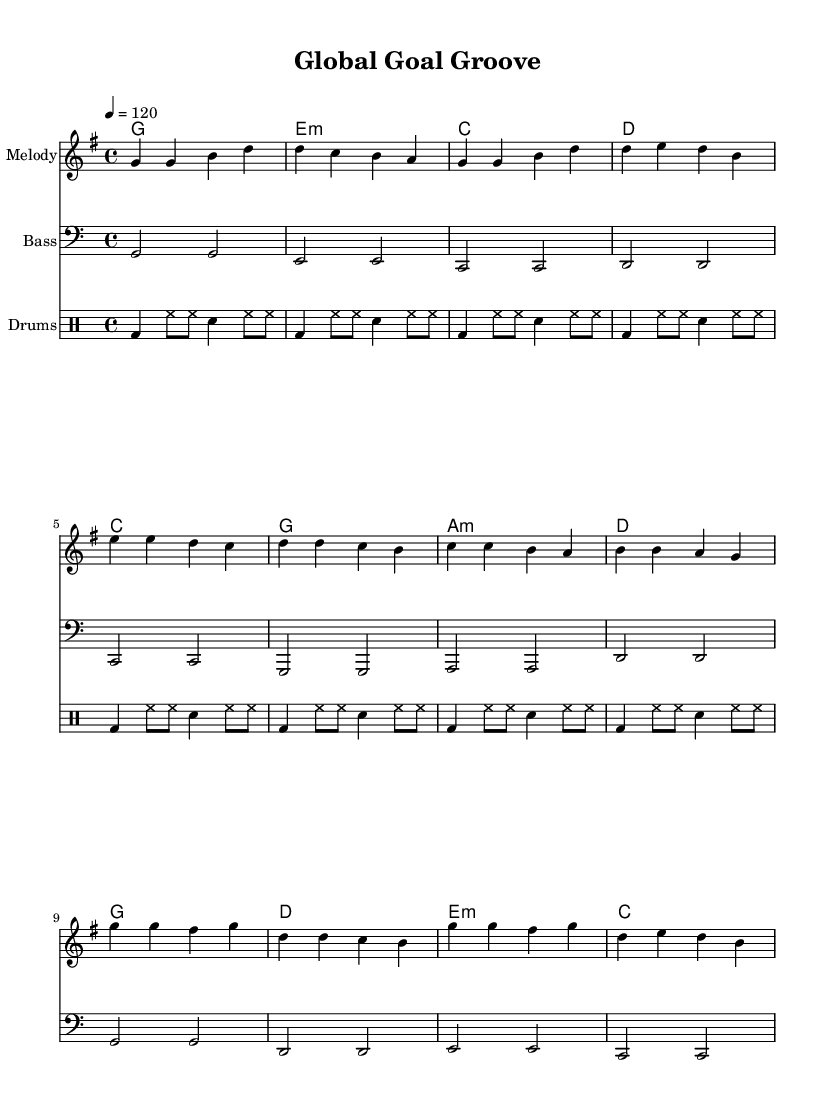What is the key signature of this music? The key signature is G major, which has one sharp (F#). This can be determined by looking at the key signature indicated at the beginning of the score, where there's a single sharp on the staff.
Answer: G major What is the time signature of this music? The time signature is 4/4, shown at the start of the score. This means there are four beats per measure, and the quarter note receives one beat.
Answer: 4/4 What is the tempo marking of this music? The tempo marking is 120 beats per minute (BPM), indicated by the text "4 = 120" at the beginning of the score. This informs the performer of the speed at which the piece should be played.
Answer: 120 How many measures are in the melody section? The melody section consists of 12 measures. This can be counted by looking at the grouping of notes and the vertical lines separating each measure in the score.
Answer: 12 What type of drum pattern is used in this piece? The drum pattern consists of bass drums, hi-hats, and snare drums, indicated by the specific notation under the drum staff. This pattern is typical for creating a pop rhythm.
Answer: Bass and snare Which chord is played during the chorus? The chords played during the chorus are G, D, E minor, and C. This can be seen in the chord names written above the melody line during the chorus section of the piece.
Answer: G, D, E minor, C How many times is the bass line repeated in the verse section? The bass line is repeated four times in the verse section, which can be identified by the repeating notation in the score under the bass staff.
Answer: Four times 